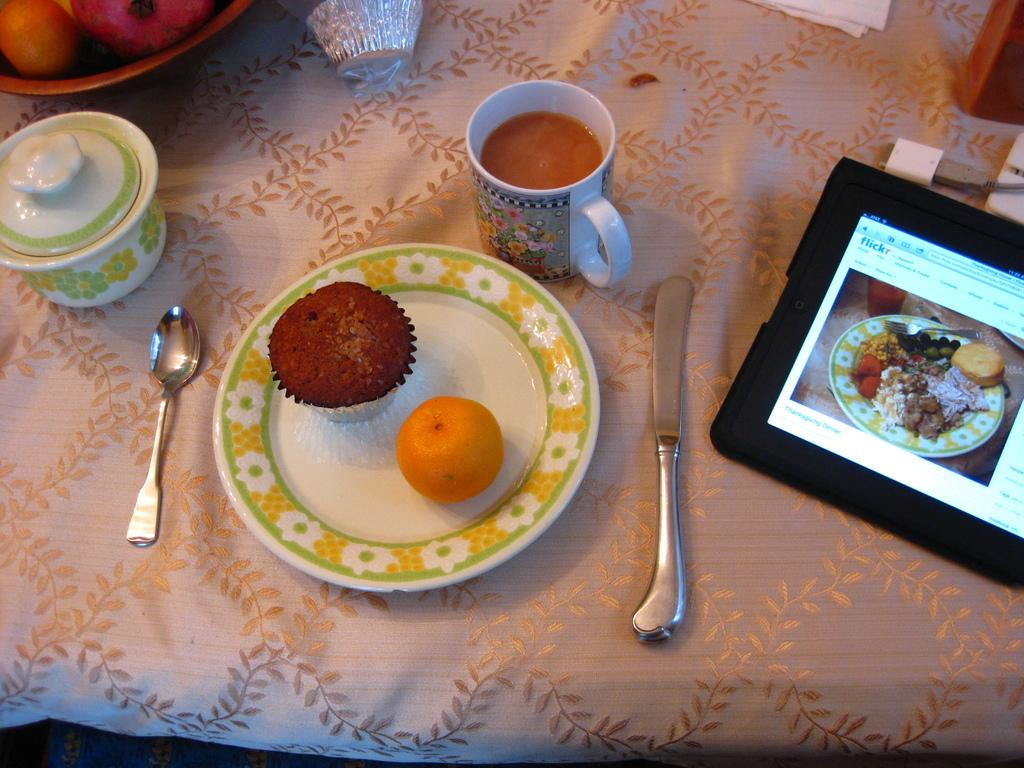What utensil can be seen in the image? There is a spoon in the image. What is on the plate in the image? There is food in a plate in the image. What other utensil is visible in the image? There is a knife in the image. What type of beverage container is present in the image? There is a teacup in the image. What electronic device is on the table in the image? There is an iPad on the table in the image. What type of straw is used to stir the food in the image? There is no straw present in the image; the food is on a plate and not in a liquid form. 